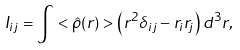<formula> <loc_0><loc_0><loc_500><loc_500>I _ { i j } = \int < \hat { \rho } ( { r } ) > \left ( r ^ { 2 } \delta _ { i j } - r _ { i } r _ { j } \right ) d ^ { 3 } r ,</formula> 